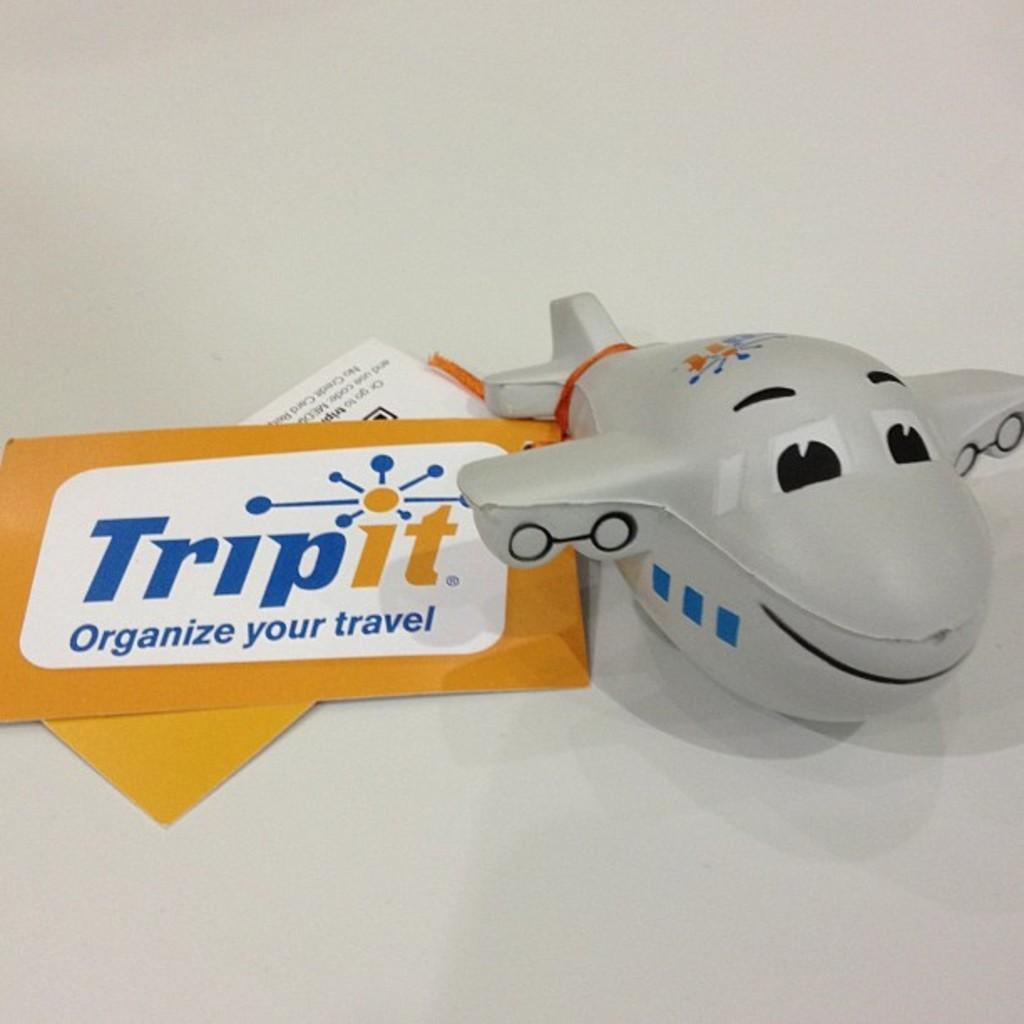What is the main object in the image? There is an aeroplane toy in the image. What colors are used for the aeroplane toy? The aeroplane toy is white and black in color. What is the color of the surface the aeroplane toy is placed on? The aeroplane toy is on a white colored surface. How many papers are in the image? There are two papers in the image. What are the colors of the papers? One paper is orange in color, and the other paper is white in color. Can you tell me how many cacti are in the image? There are no cacti present in the image. What type of drink is being served in the image? The image does not show any drinks, so it cannot be determined what type of drink is being served. 